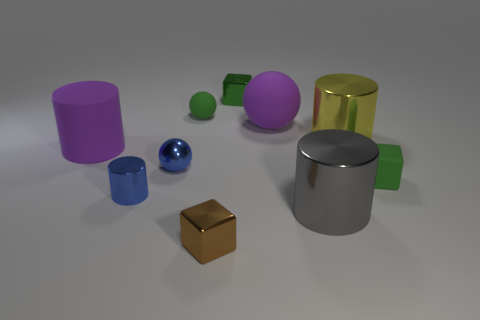What number of blue cylinders are right of the blue shiny object that is on the left side of the small blue metallic sphere in front of the green sphere?
Offer a very short reply. 0. There is a green metal object that is the same shape as the brown thing; what is its size?
Provide a short and direct response. Small. Are there any other things that are the same size as the blue metallic sphere?
Keep it short and to the point. Yes. Are there fewer large gray shiny things in front of the big gray shiny object than blocks?
Give a very brief answer. Yes. Is the shape of the gray metal object the same as the small brown shiny object?
Give a very brief answer. No. The rubber thing that is the same shape as the big yellow shiny object is what color?
Give a very brief answer. Purple. How many objects are the same color as the small shiny sphere?
Your answer should be compact. 1. What number of objects are either big cylinders that are on the left side of the big purple rubber sphere or tiny purple shiny cubes?
Offer a very short reply. 1. What is the size of the green block that is behind the rubber cylinder?
Provide a short and direct response. Small. Are there fewer small blue cylinders than purple metal balls?
Keep it short and to the point. No. 